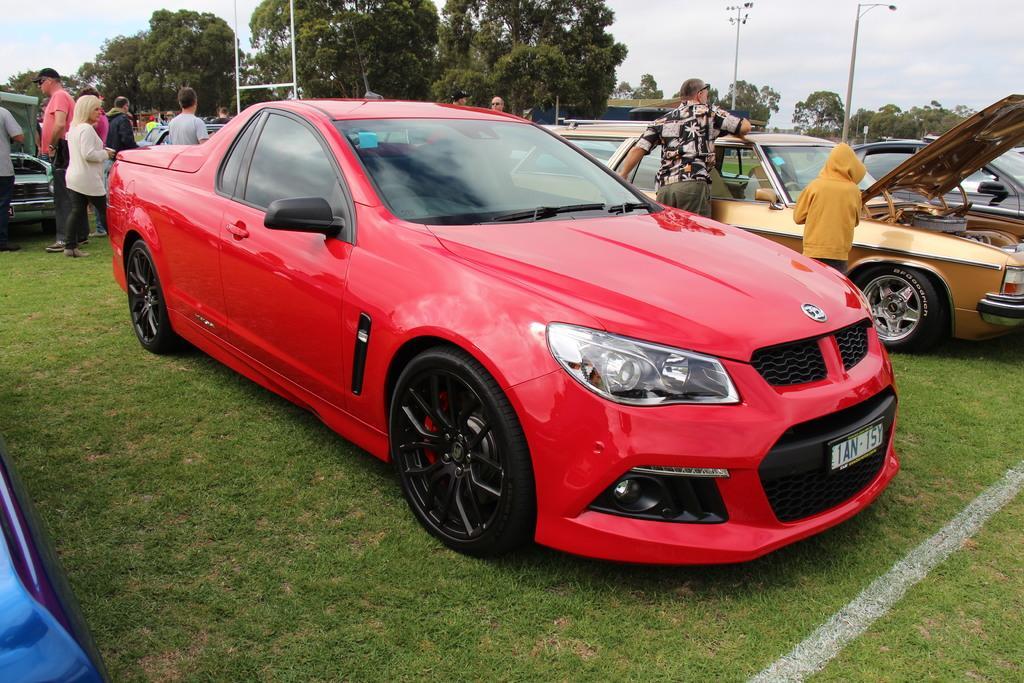Could you give a brief overview of what you see in this image? This image is taken outdoors. At the top of the image there is a sky with clouds. At the bottom of the image there is a ground with grass on it. In the background there are many trees with leaves, stems and branches. There are two poles. In the middle of the image many cars are parked on the ground. A few people are standing on the ground and a few are walking. 